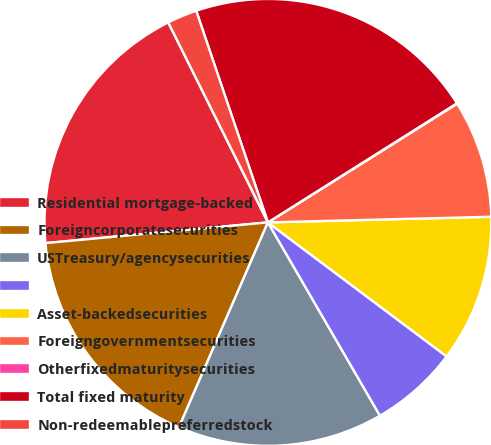Convert chart to OTSL. <chart><loc_0><loc_0><loc_500><loc_500><pie_chart><fcel>Residential mortgage-backed<fcel>Foreigncorporatesecurities<fcel>USTreasury/agencysecurities<fcel>Unnamed: 3<fcel>Asset-backedsecurities<fcel>Foreigngovernmentsecurities<fcel>Otherfixedmaturitysecurities<fcel>Total fixed maturity<fcel>Non-redeemablepreferredstock<nl><fcel>19.12%<fcel>17.0%<fcel>14.88%<fcel>6.4%<fcel>10.64%<fcel>8.52%<fcel>0.03%<fcel>21.25%<fcel>2.16%<nl></chart> 